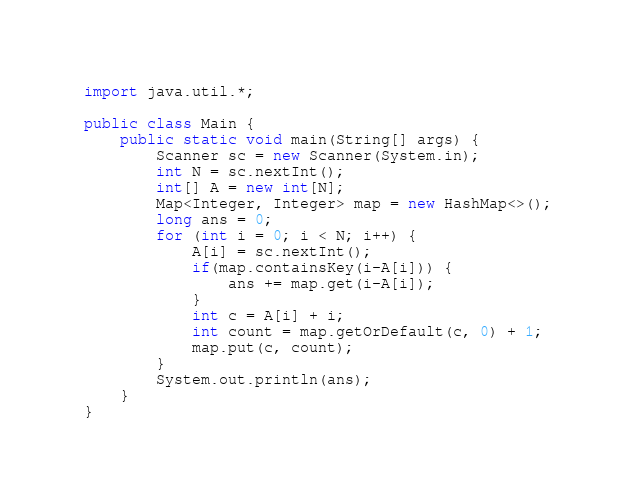<code> <loc_0><loc_0><loc_500><loc_500><_Java_>import java.util.*;

public class Main {
    public static void main(String[] args) {
        Scanner sc = new Scanner(System.in);
        int N = sc.nextInt();
        int[] A = new int[N];
        Map<Integer, Integer> map = new HashMap<>();
        long ans = 0;
        for (int i = 0; i < N; i++) {
            A[i] = sc.nextInt();
            if(map.containsKey(i-A[i])) {
                ans += map.get(i-A[i]);
            }
            int c = A[i] + i;
            int count = map.getOrDefault(c, 0) + 1;
            map.put(c, count);
        }
        System.out.println(ans);
    }
}</code> 